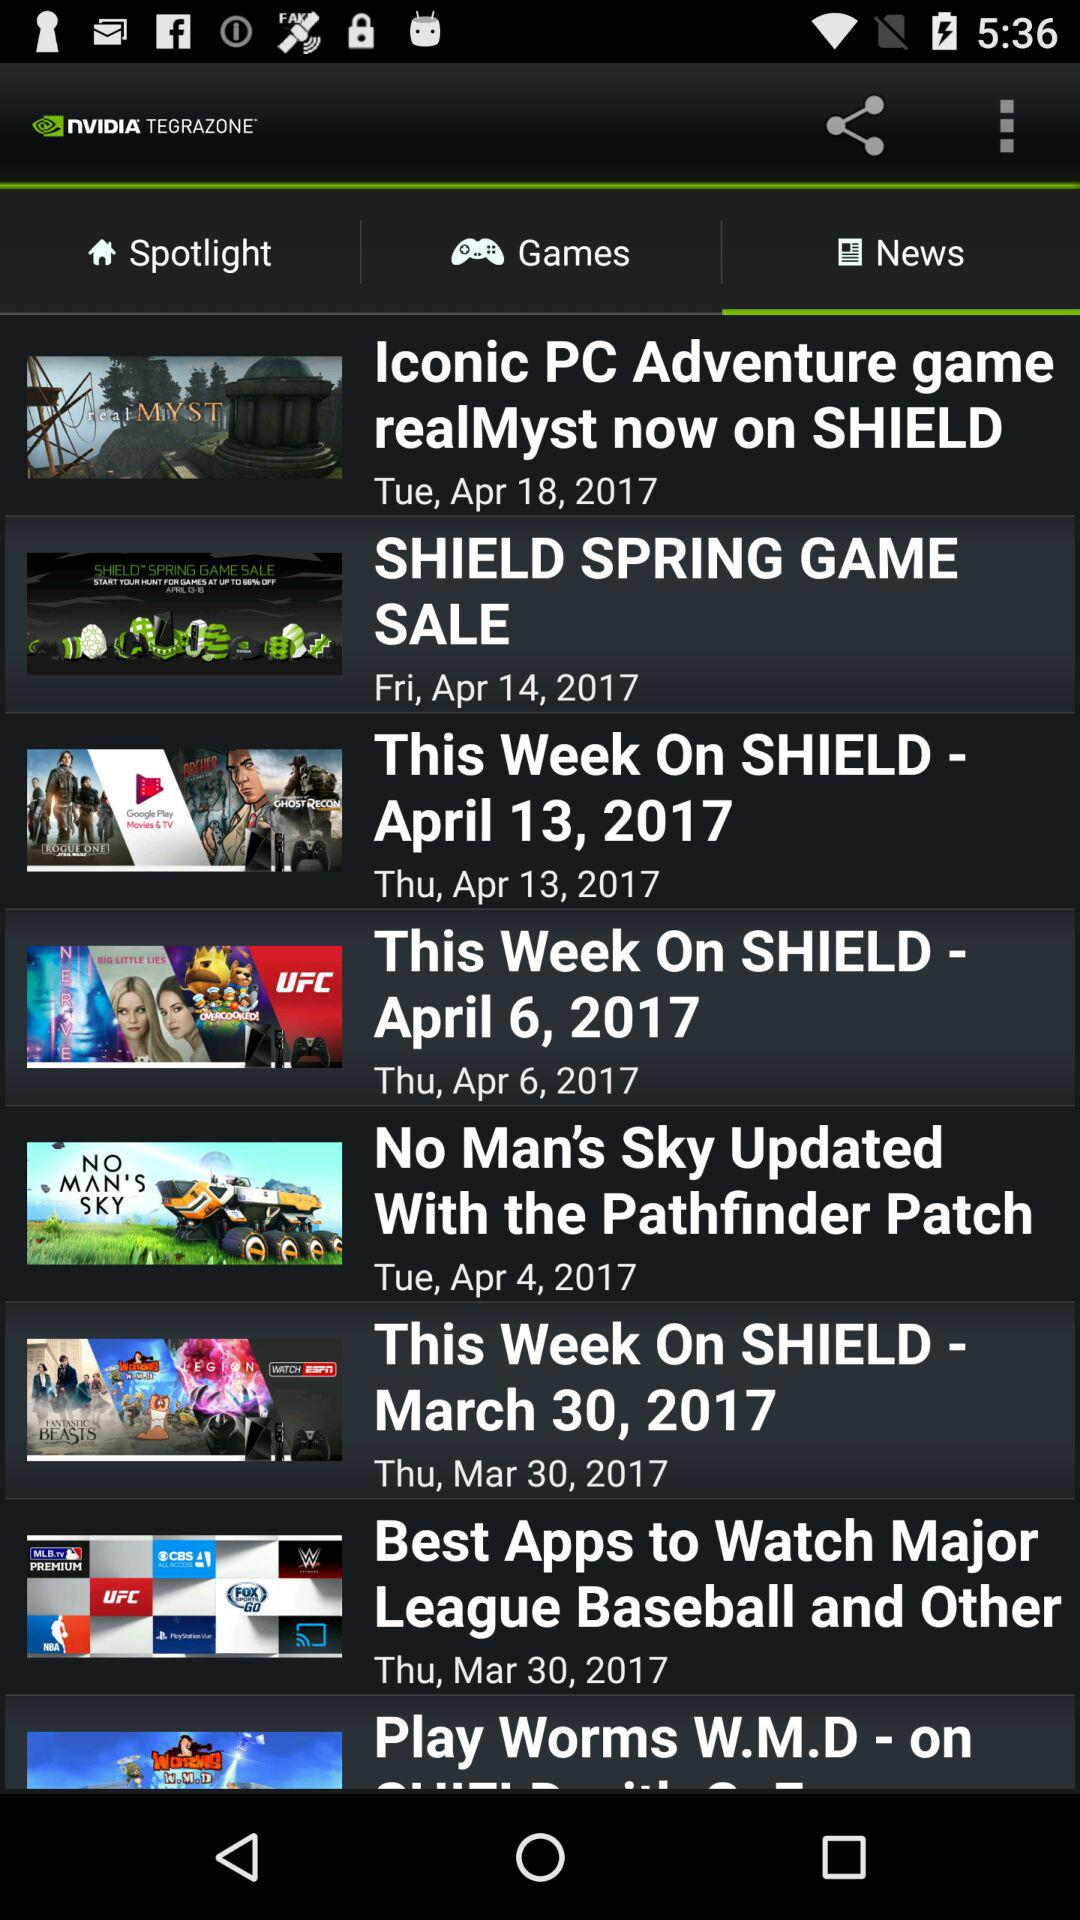What are the available news headlines? The available news headlines are "Iconic PC Adventure game realMyst now on SHIELD", "SHIELD SPRING GAME SALE", "This Week On SHIELD - April 13, 2017", "This Week On SHIELD - April 6, 2017," "No Man's Sky Updated With the Pathfinder Patch", "This Week On SHIELD - March 30, 2017" and "League Baseball and Other". 